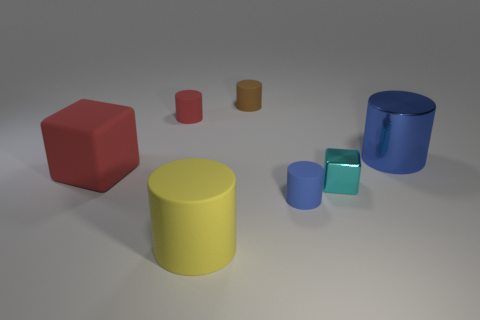How many objects in the image are not cylinders? There are three objects in the image that are not cylinders: one large red cube, one large red block, and one tiny red cylinder. What colors are the cylindrical objects? The cylindrical objects in the image are colored yellow, blue, and two shades of green. 